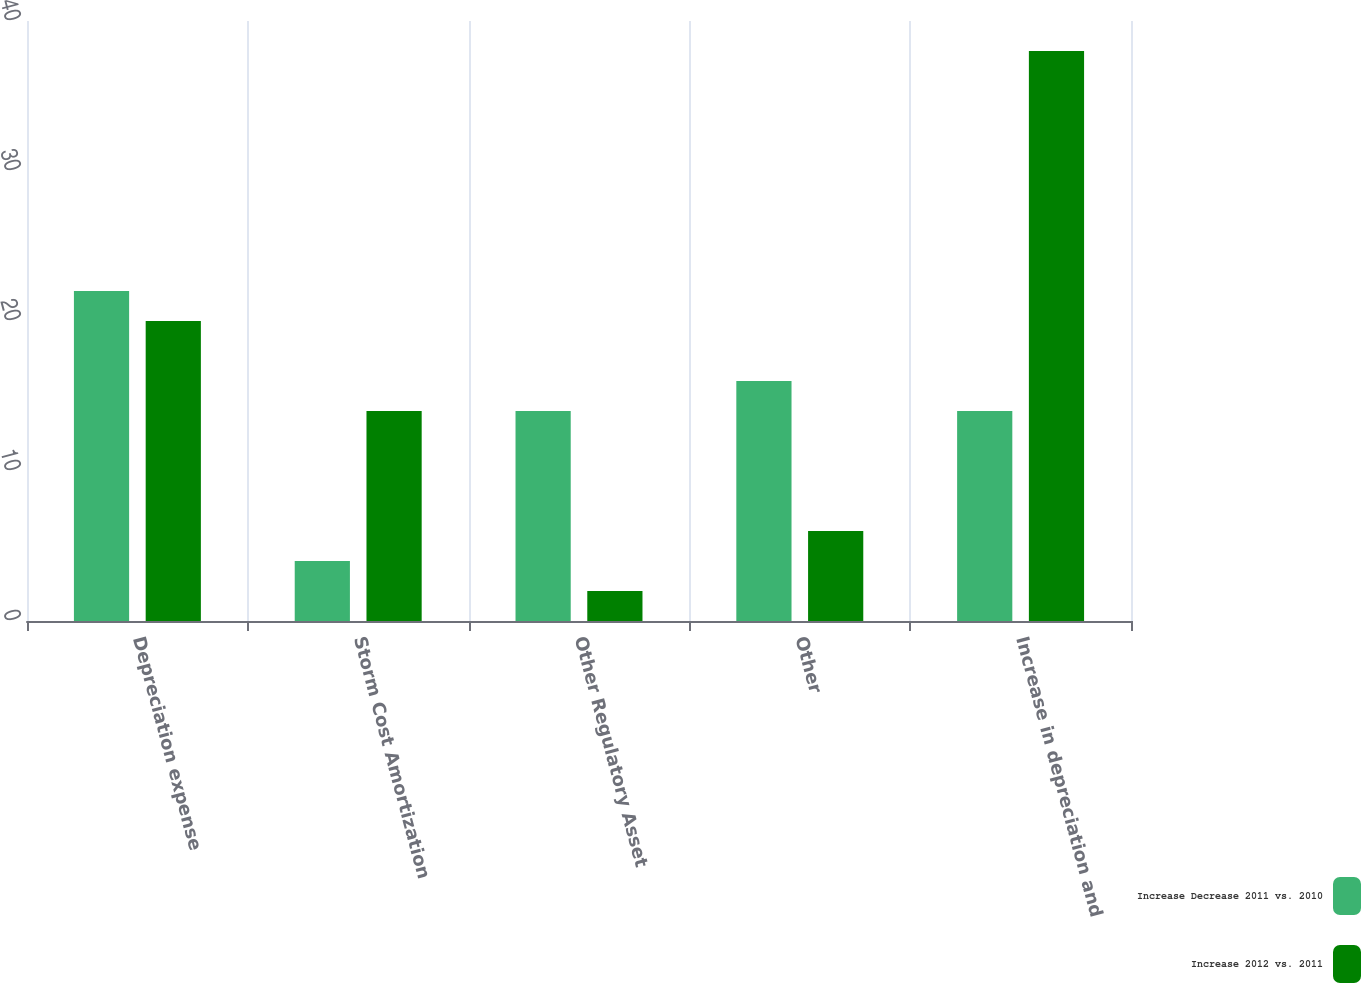Convert chart. <chart><loc_0><loc_0><loc_500><loc_500><stacked_bar_chart><ecel><fcel>Depreciation expense<fcel>Storm Cost Amortization<fcel>Other Regulatory Asset<fcel>Other<fcel>Increase in depreciation and<nl><fcel>Increase Decrease 2011 vs. 2010<fcel>22<fcel>4<fcel>14<fcel>16<fcel>14<nl><fcel>Increase 2012 vs. 2011<fcel>20<fcel>14<fcel>2<fcel>6<fcel>38<nl></chart> 